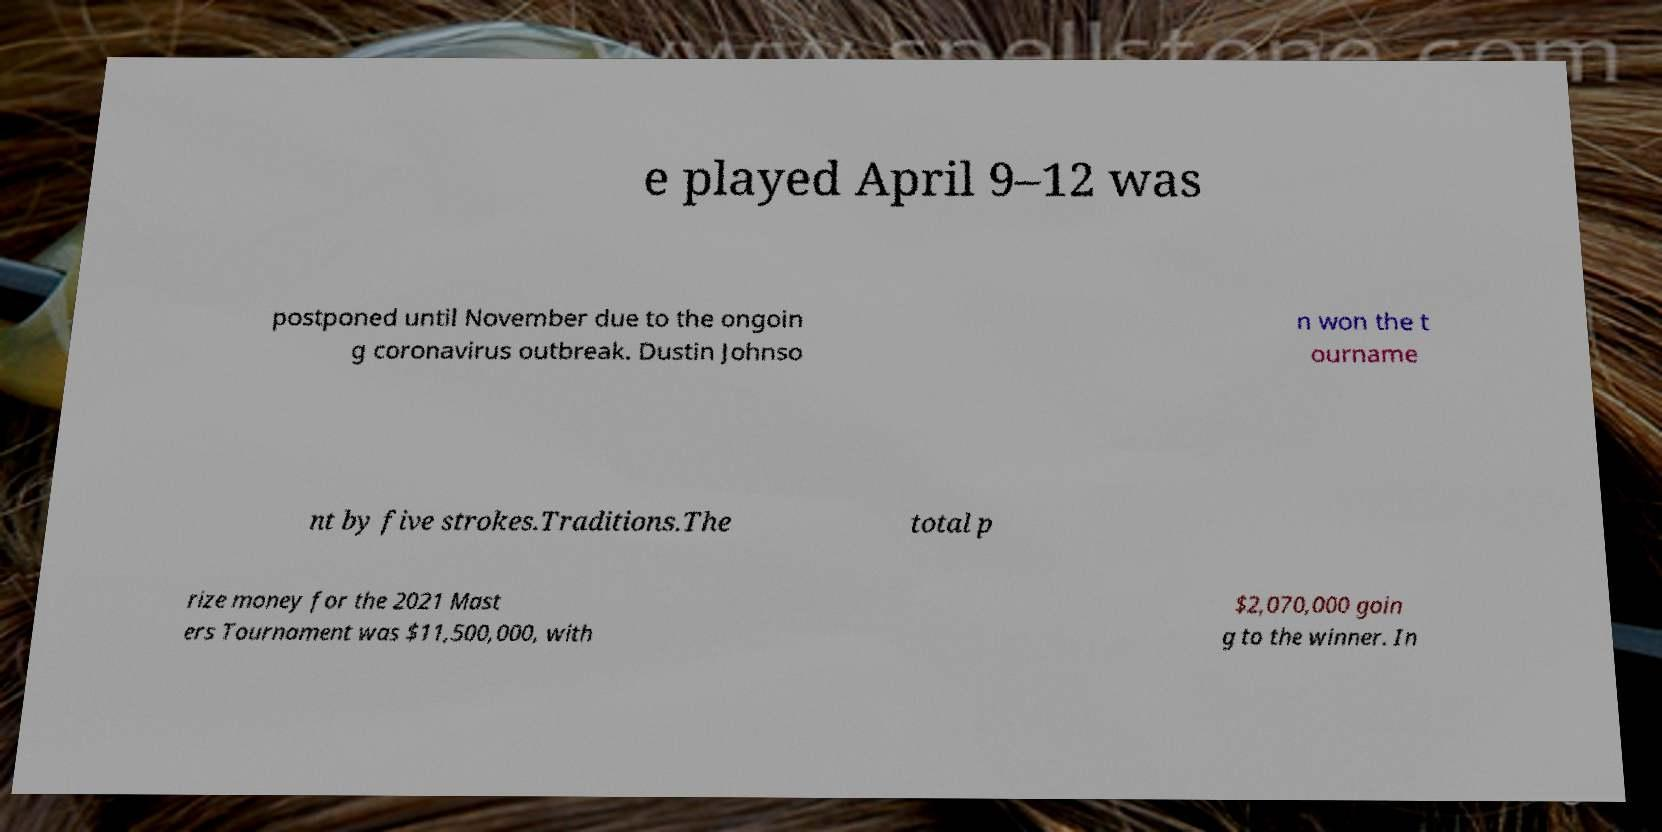Could you assist in decoding the text presented in this image and type it out clearly? e played April 9–12 was postponed until November due to the ongoin g coronavirus outbreak. Dustin Johnso n won the t ourname nt by five strokes.Traditions.The total p rize money for the 2021 Mast ers Tournament was $11,500,000, with $2,070,000 goin g to the winner. In 